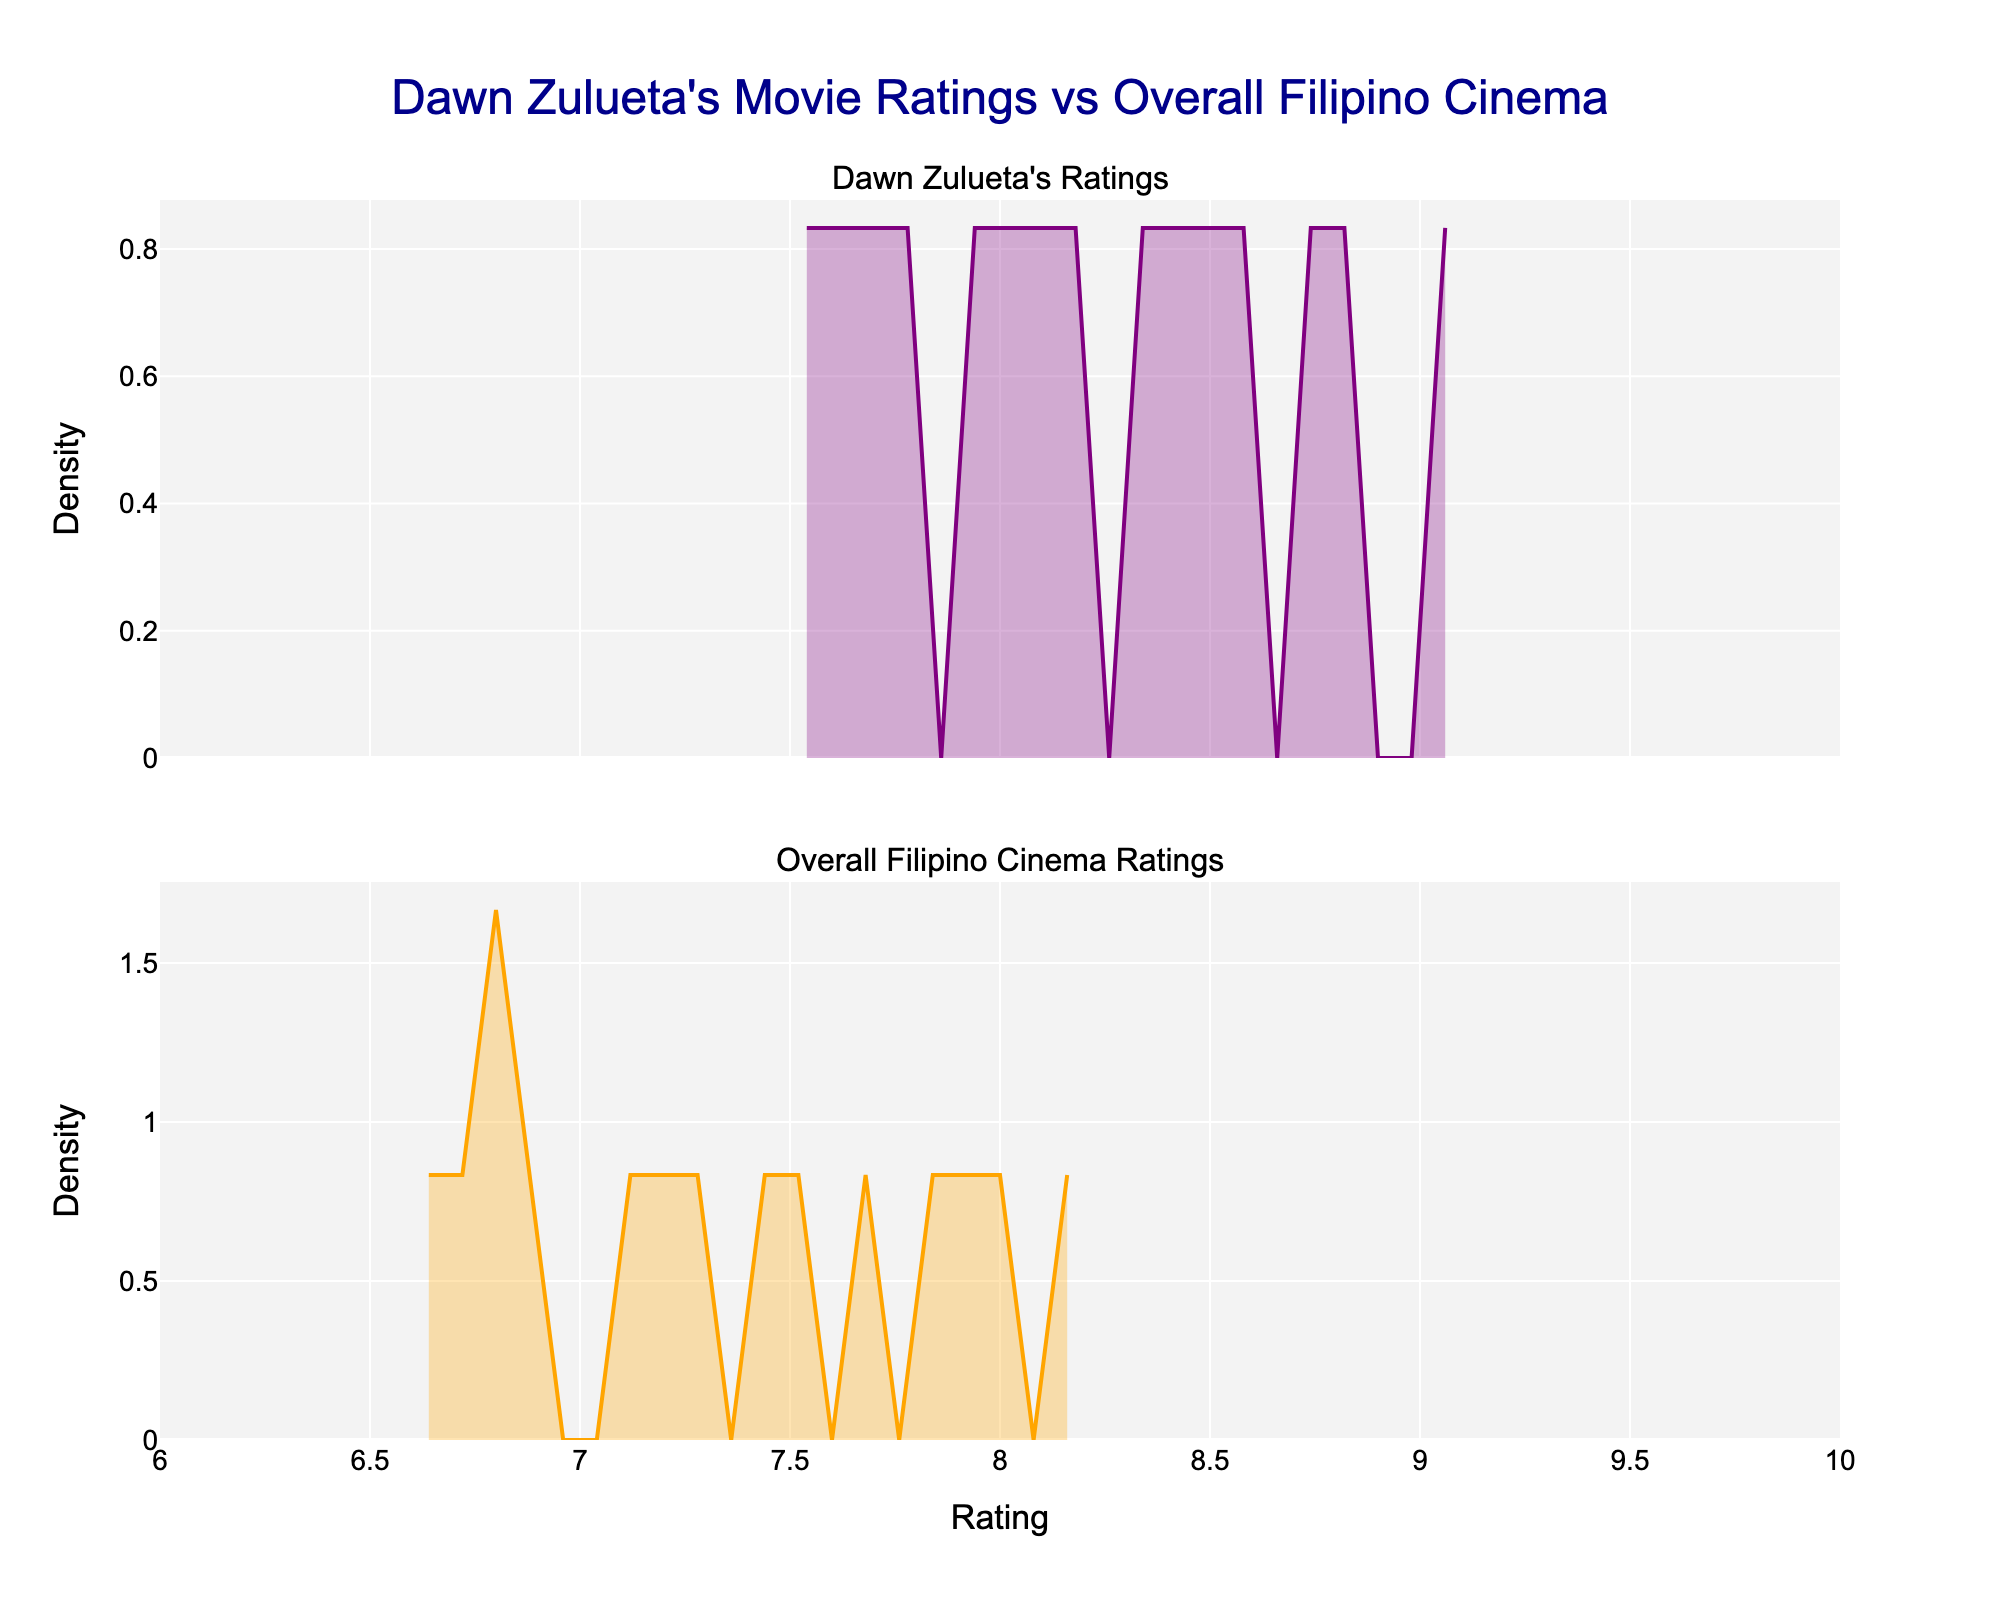What is the title of the plot? The title appears at the top of the plot, which reads "Dawn Zulueta's Movie Ratings vs Overall Filipino Cinema." This gives an overview of what the figure is comparing.
Answer: Dawn Zulueta's Movie Ratings vs Overall Filipino Cinema What are the x-axis and y-axis labels in each subplot? For both subplots, the x-axis is labeled "Rating" and each subplot has a y-axis labeled "Density." The x-axis ranges from 6 to 10, and the y-axis label denotes the KDE density.
Answer: Rating and Density What color is used for Dawn Zulueta's ratings? The density plot for Dawn Zulueta's ratings uses purple with a partially transparent fill.
Answer: Purple What color is used for Overall Filipino Cinema ratings? The density plot for Overall Filipino Cinema ratings uses orange with a partially transparent fill.
Answer: Orange Which subplot has a higher density peak? Dawn Zulueta's ratings subplot in purple has a higher density peak than the overall Filipino cinema ratings subplot in orange. This indicates that Dawn Zulueta's movies tend to have higher ratings.
Answer: Dawn Zulueta's ratings Is there any overlap between the density plots of Dawn Zulueta's movies and the overall Filipino Cinema? By visually inspecting the plots, it is evident that the density curves overlap in the ratings range, especially around the higher ratings from 7 to 9. This indicates that the ratings distributions intersect within this range.
Answer: Yes In which rating range do Dawn Zulueta's movies dominate the density plot compared to overall Filipino cinema? Dawn Zulueta's movies dominate the density plot in the higher rating ranges from around 8 to 9.5, where the density plots show a higher peak for her movies compared to overall Filipino cinema.
Answer: 8 to 9.5 Which has a lower minimum density value, Dawn Zulueta's movies or overall Filipino cinema? Based on the density plots, the linear plot for the overall Filipino cinema (in orange) seems to show more values approaching zero than Dawn Zulueta's ratings plot, indicating a lower minimum density for the overall Filipino cinema.
Answer: Overall Filipino cinema How do the density plots change as the rating goes from 7 to 9? As the rating increases from 7 to 9, the density plot for Dawn Zulueta's movies rises more sharply and peaks higher compared to the overall Filipino cinema, which suggests that higher ratings are more prevalent in Dawn Zulueta's movies.
Answer: The density for Dawn Zulueta's movies rises more sharply What can you infer about the distribution of ratings for Dawn Zulueta's movies compared to overall Filipino cinema? Dawn Zulueta's movies generally have higher ratings compared to the overall Filipino cinema, as evidenced by the higher peaks and higher density in the upper rating ranges. Her films consistently perform better in terms of ratings.
Answer: Higher ratings for Dawn Zulueta's movies 